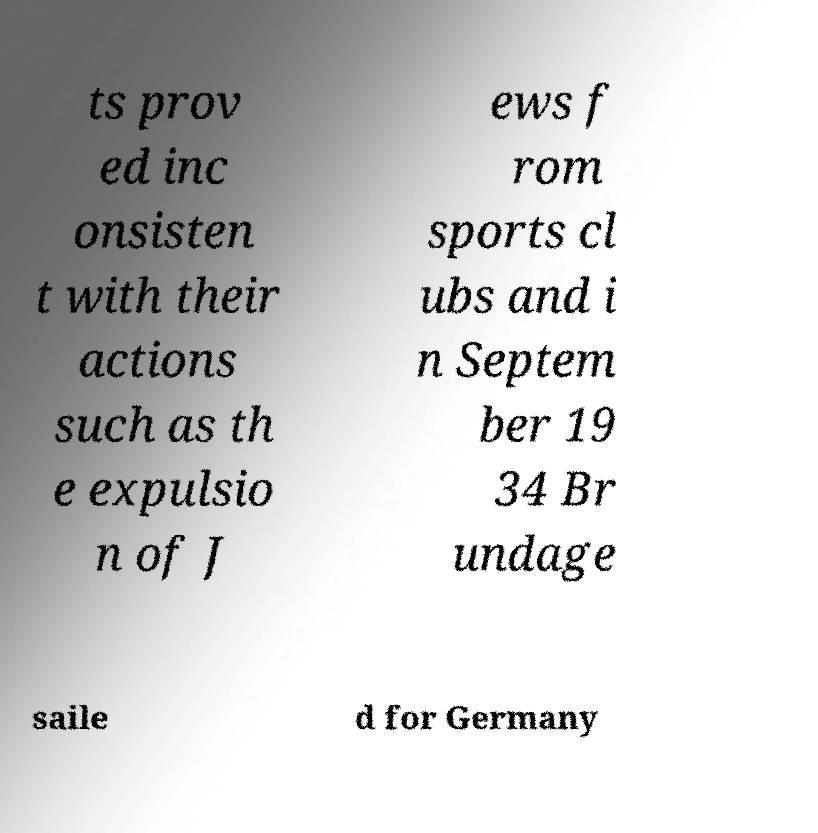Please identify and transcribe the text found in this image. ts prov ed inc onsisten t with their actions such as th e expulsio n of J ews f rom sports cl ubs and i n Septem ber 19 34 Br undage saile d for Germany 